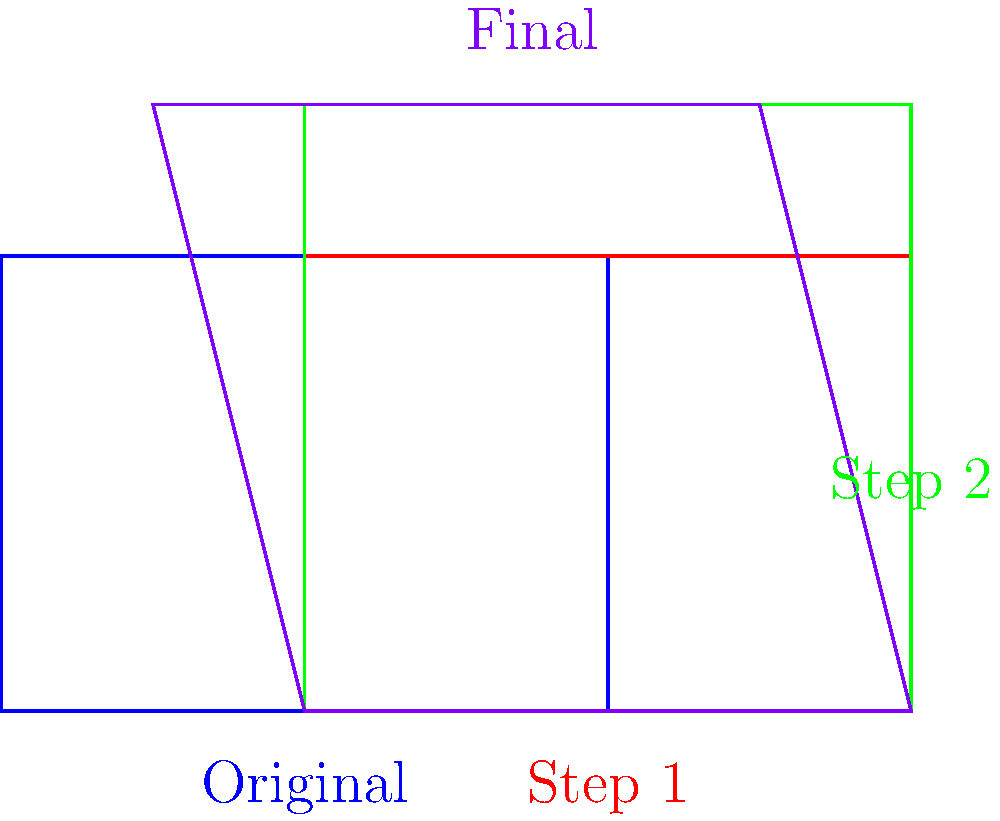As a pet owner designing a bird cage for your children's new pet, you start with a basic rectangular design and apply a series of transformations. The image shows the original design (blue) and three subsequent transformations (red, green, and purple). Determine the sequence of transformations applied to reach the final design (purple). Let's analyze the transformations step by step:

1. From blue to red:
   The shape moves 2 units to the right without changing its size or orientation.
   This is a translation of 2 units in the positive x-direction.

2. From red to green:
   The shape maintains its position but increases in height from 3 units to 4 units.
   This is a vertical scaling with a scale factor of 4/3 or 1.33.

3. From green to purple:
   The shape's top edge is tilted, with the left side moving down and the right side moving up.
   This is a shear transformation parallel to the y-axis.

Therefore, the sequence of transformations is:
1. Translation
2. Vertical scaling
3. Shear
Answer: Translation, vertical scaling, shear 